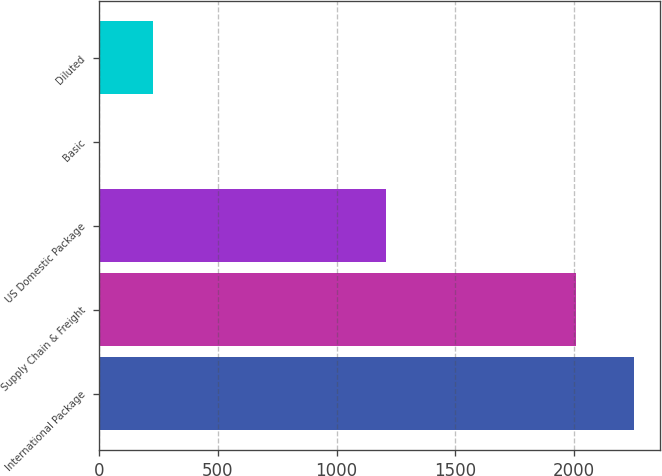Convert chart to OTSL. <chart><loc_0><loc_0><loc_500><loc_500><bar_chart><fcel>International Package<fcel>Supply Chain & Freight<fcel>US Domestic Package<fcel>Basic<fcel>Diluted<nl><fcel>2251<fcel>2009<fcel>1208<fcel>0.96<fcel>225.96<nl></chart> 